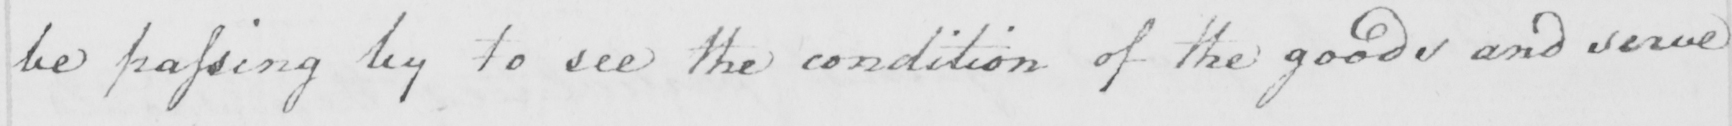What text is written in this handwritten line? be passing by to see the condition of the goods and serve 